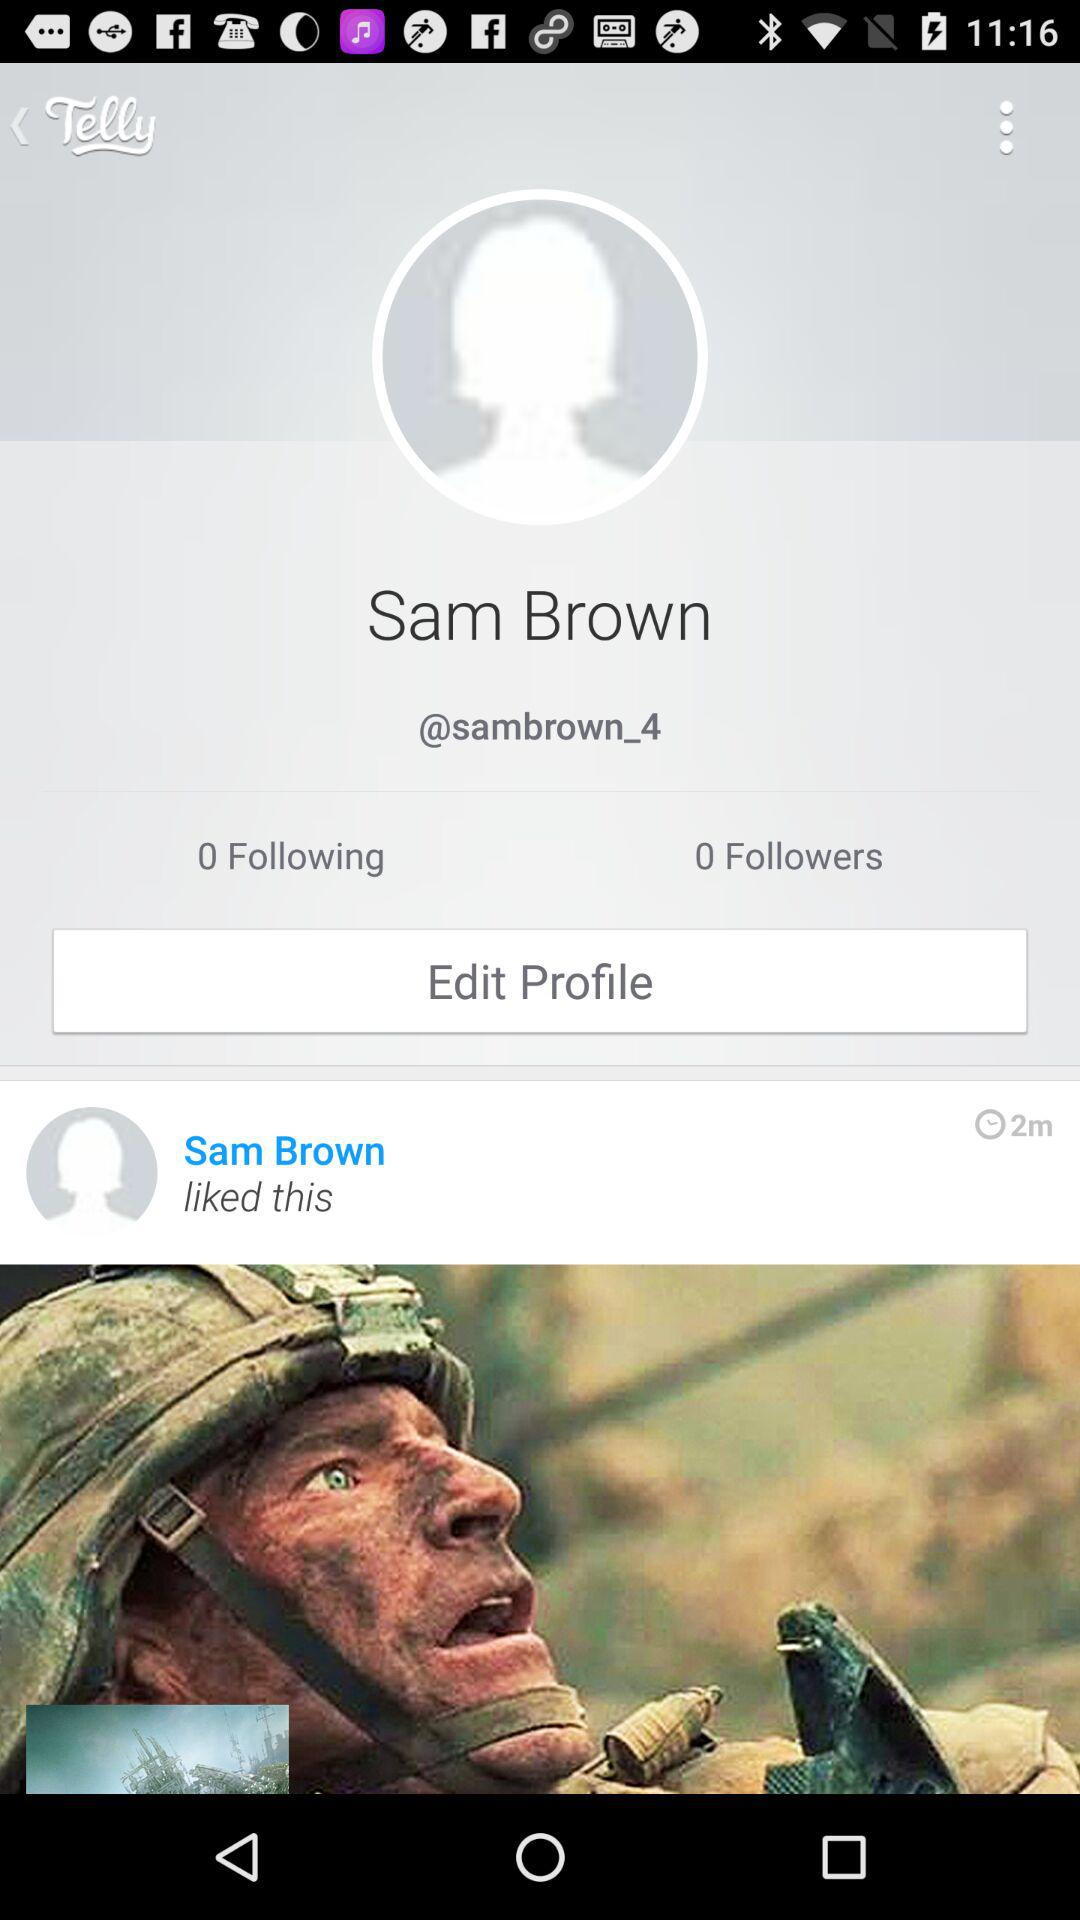What is the count of people followed by Sam Brown? Sam Brown follows 0 people. 